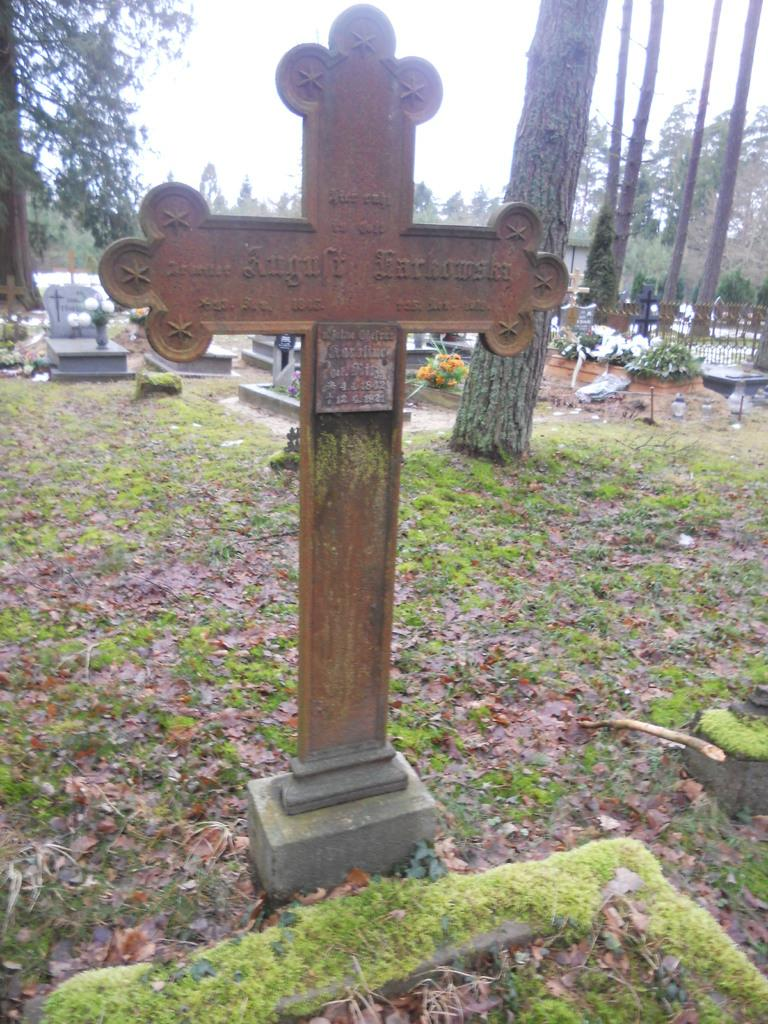What is the main symbol in the image? There is a cross symbol in the image. Where is the cross symbol located? The cross symbol is on a grassland. What can be seen in the background of the image? There are trees and the sky visible in the background of the image. What is the cause of the trees' income in the image? There is no information about the trees' income in the image, as it focuses on the cross symbol and its location on a grassland. 